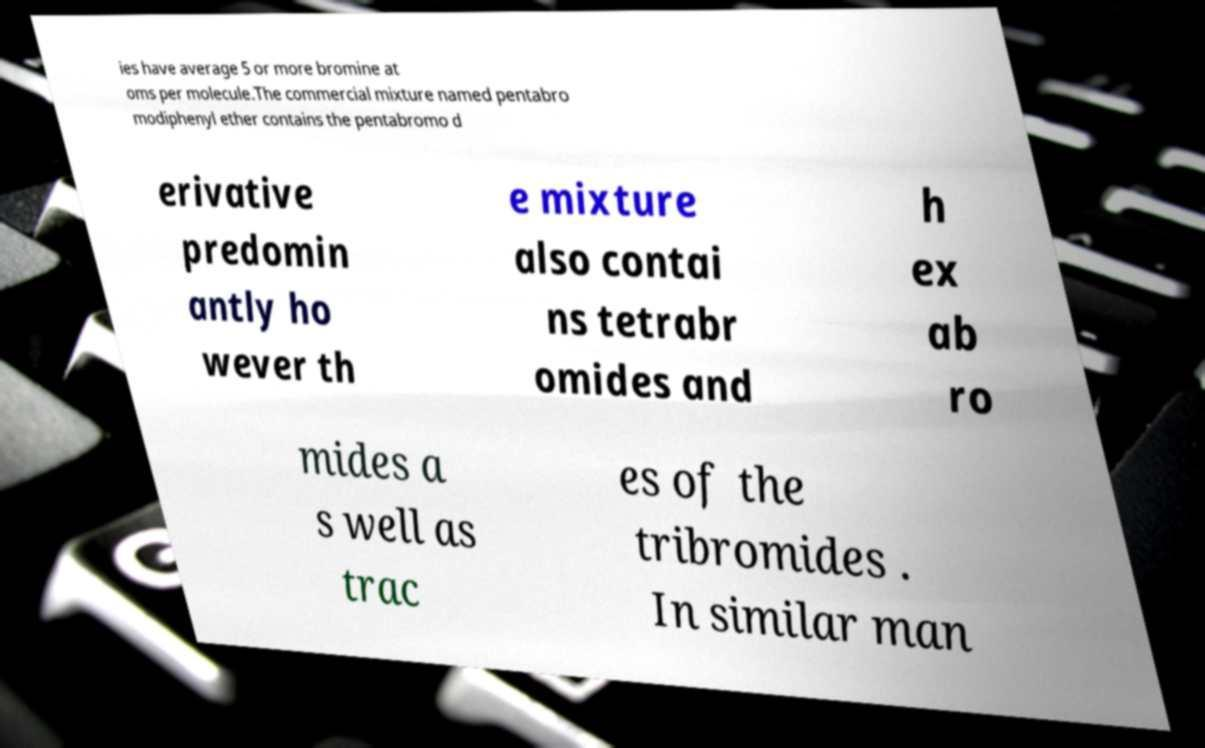Please read and relay the text visible in this image. What does it say? ies have average 5 or more bromine at oms per molecule.The commercial mixture named pentabro modiphenyl ether contains the pentabromo d erivative predomin antly ho wever th e mixture also contai ns tetrabr omides and h ex ab ro mides a s well as trac es of the tribromides . In similar man 